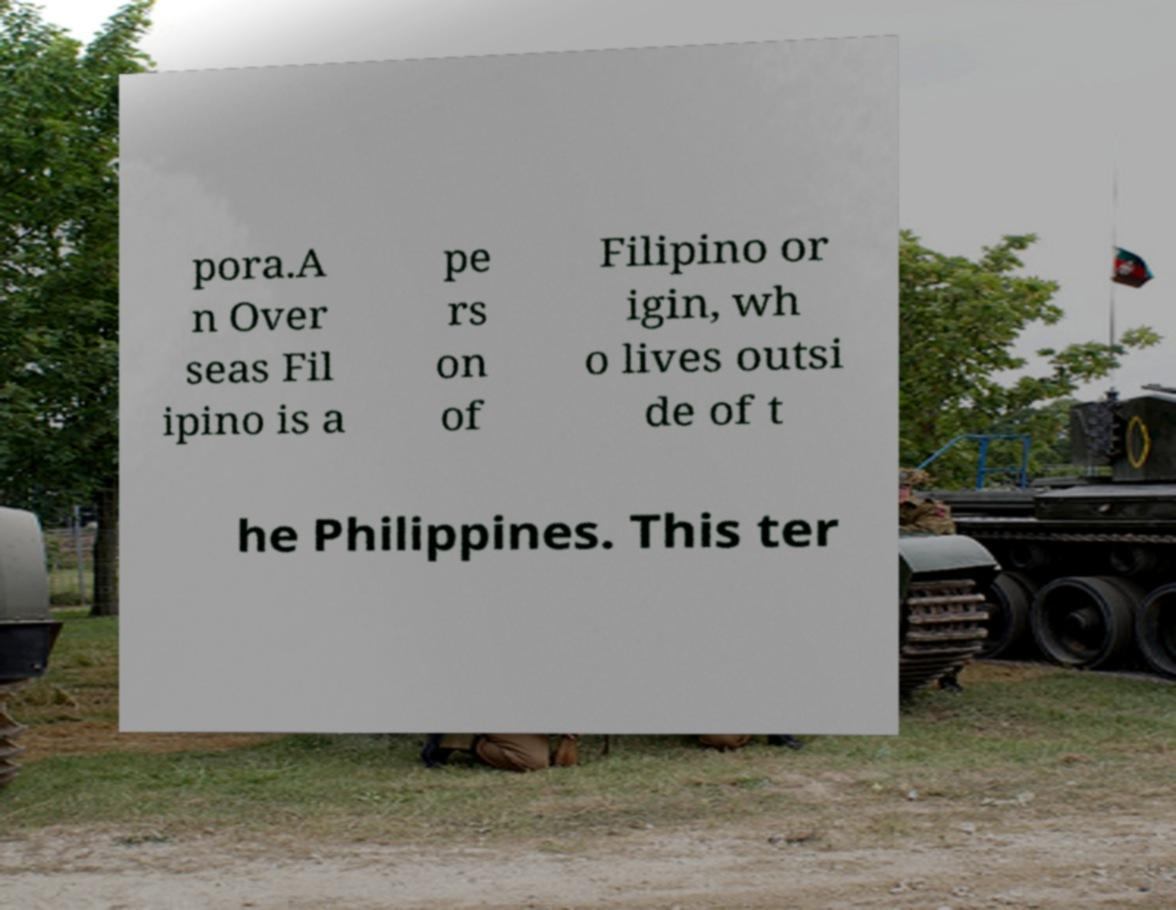Can you accurately transcribe the text from the provided image for me? pora.A n Over seas Fil ipino is a pe rs on of Filipino or igin, wh o lives outsi de of t he Philippines. This ter 